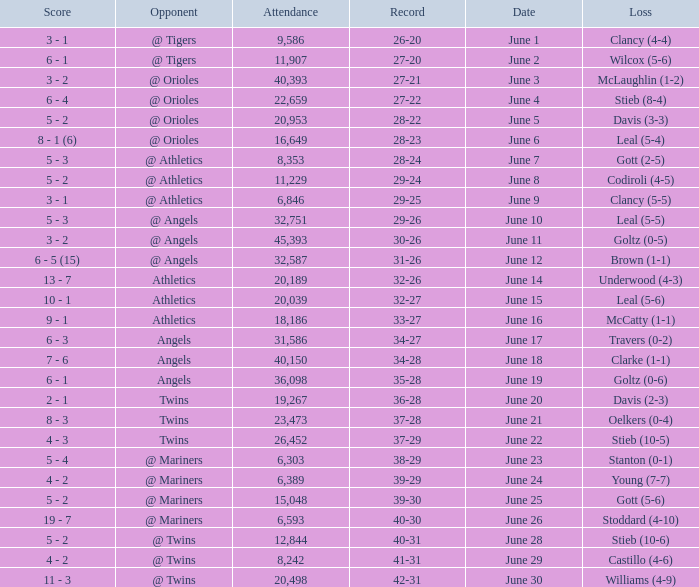What was the record for the date of June 14? 32-26. 